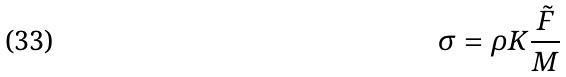<formula> <loc_0><loc_0><loc_500><loc_500>\sigma = \rho K \frac { \tilde { F } } { M }</formula> 